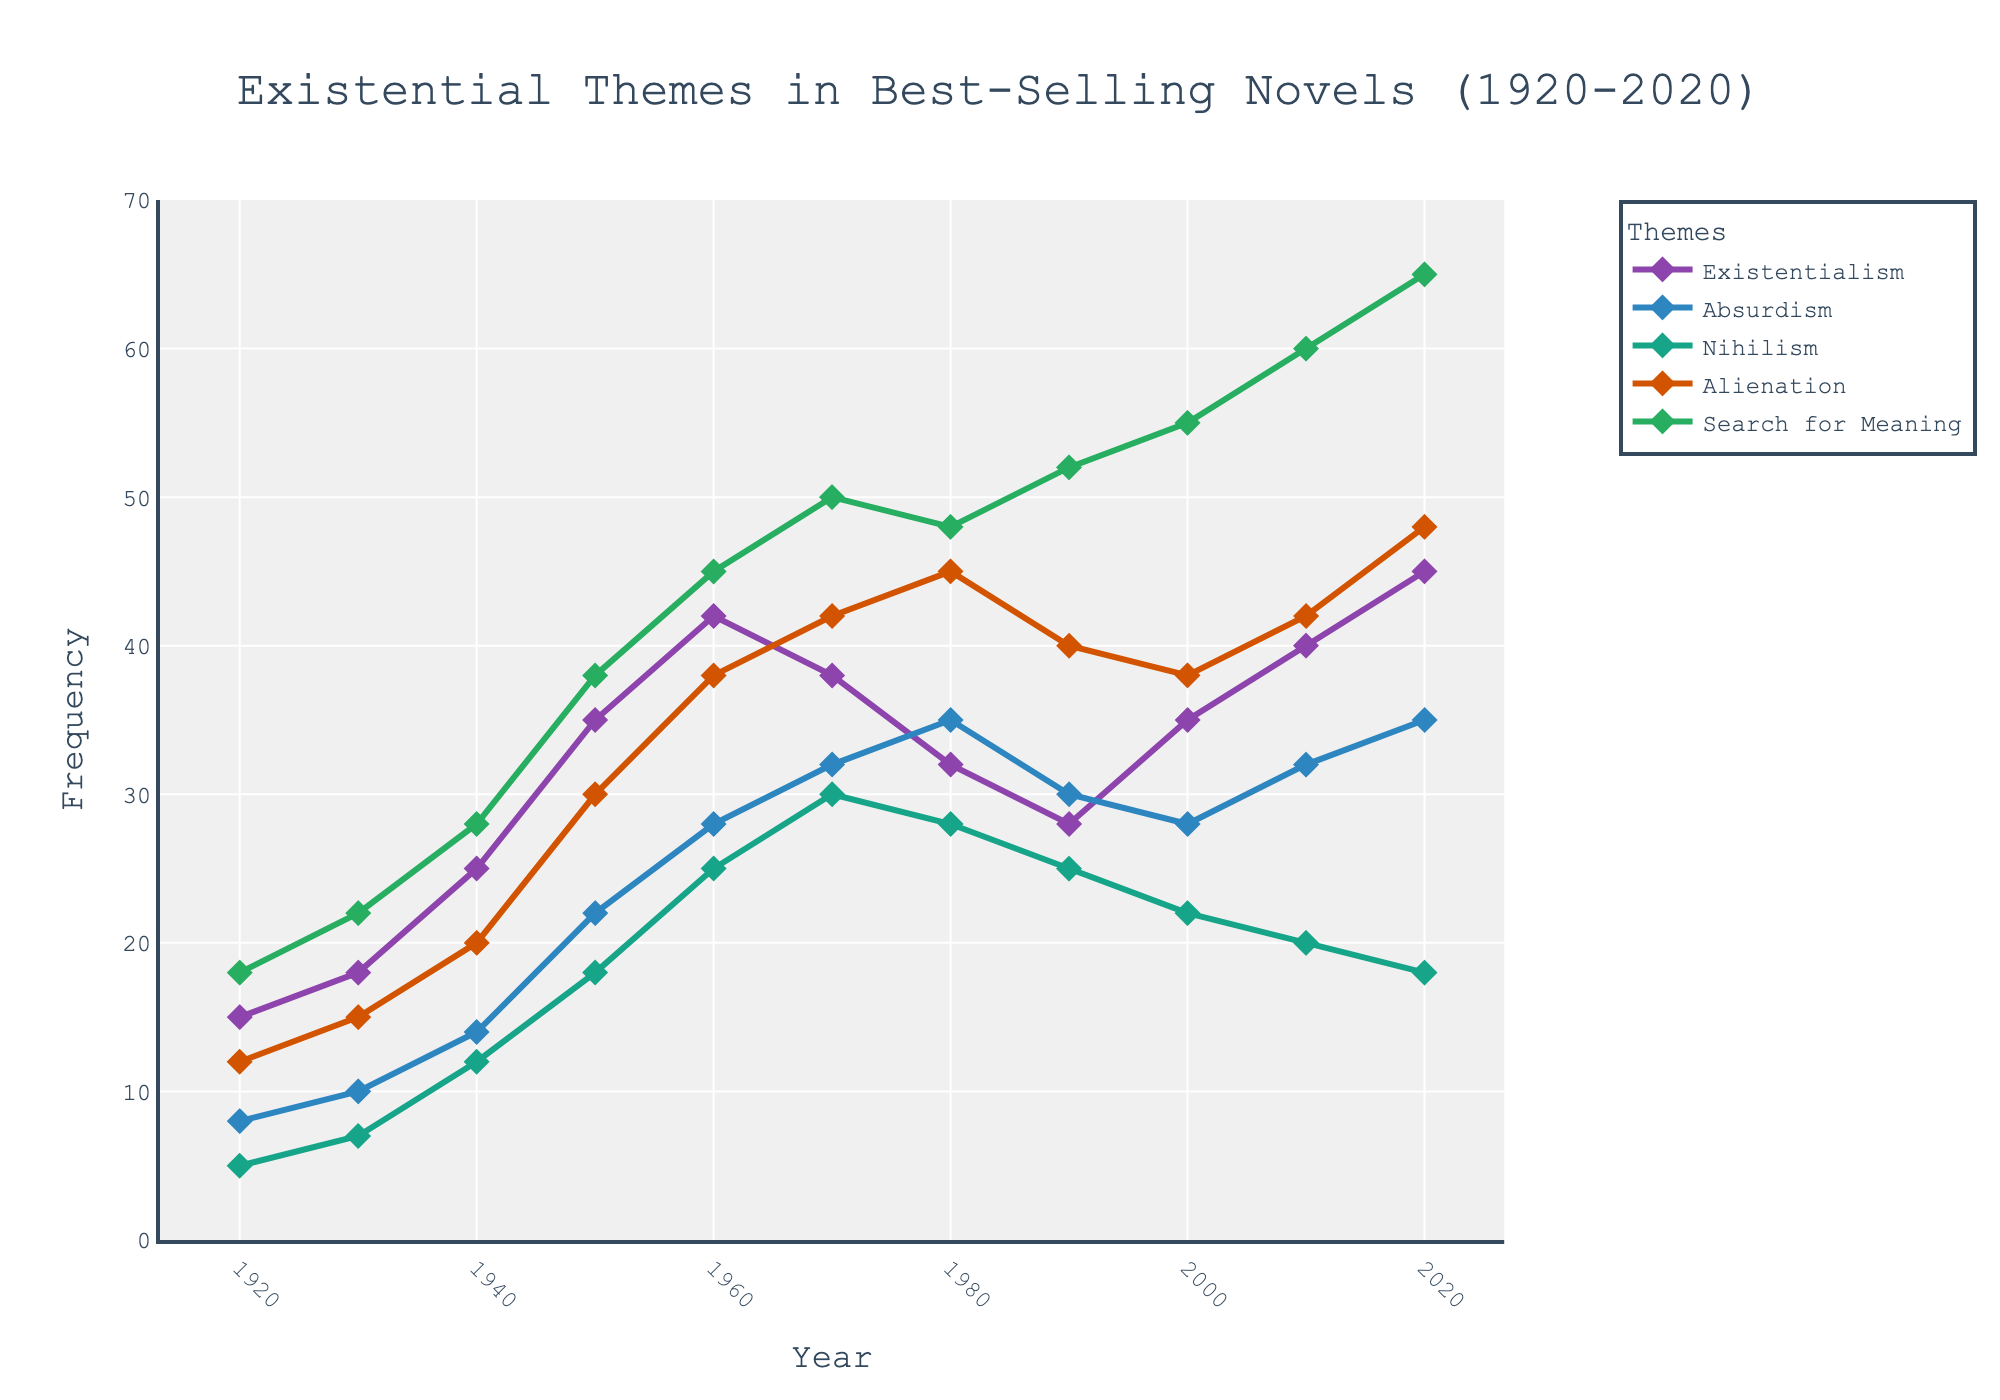Which existential theme shows a steady increase in frequency from 1920 to 2020? By inspecting the trend lines, we can see that the "Search for Meaning" theme has a steady increase throughout the entire period from 1920 to 2020.
Answer: Search for Meaning Which year had the highest frequency for Nihilism, and what was the value? By observing the graph, we find that 1970 had the highest frequency for Nihilism at a value of 30.
Answer: 1970, 30 In which decade did Absurdism surpass Existentialism in terms of frequency for the first time? By examining the trend lines, Absurdism first surpasses Existentialism in 1980.
Answer: 1980 What is the combined frequency of Alienation and Existentialism in 1920? Sum the frequencies of Alienation and Existentialism in 1920 from the data: 12 + 15.
Answer: 27 How much did the frequency of Existentialism change between 1950 and 2020? Subtract the frequency of Existentialism in 1950 from its frequency in 2020: 45 - 35.
Answer: 10 Which existential theme had the largest increase between 2000 and 2010? Calculate the change for each theme between 2000 and 2010 and compare:
Existentialism: 40 - 35 = 5
Absurdism: 32 - 28 = 4
Nihilism: 20 - 22 = (-2)
Alienation: 42 - 38 = 4
Search for Meaning: 60 - 55 = 5
"Search for Meaning" and "Existentialism" both increased by 5.
Answer: Existentialism and Search for Meaning Which year's data point for Alienation is represented as an orange diamond marker? By matching colors to lines and markers, the orange markers indicate Alienation. The data point for Alienation in 2010 is 42.
Answer: 2010 Compare the frequencies of 'Search for Meaning' and 'Alienation' in 1960. Which is higher and by how much? Subtract the frequency of Alienation from the Search for Meaning in 1960: 45 - 38.
Answer: Search for Meaning is higher by 7 What is the average frequency of Absurdism across the decades represented in the data? Average is calculated by summing all the frequencies for Absurdism and dividing by the number of data points (11). Sum = 228. Divide by 11: 228/11.
Answer: 20.73 